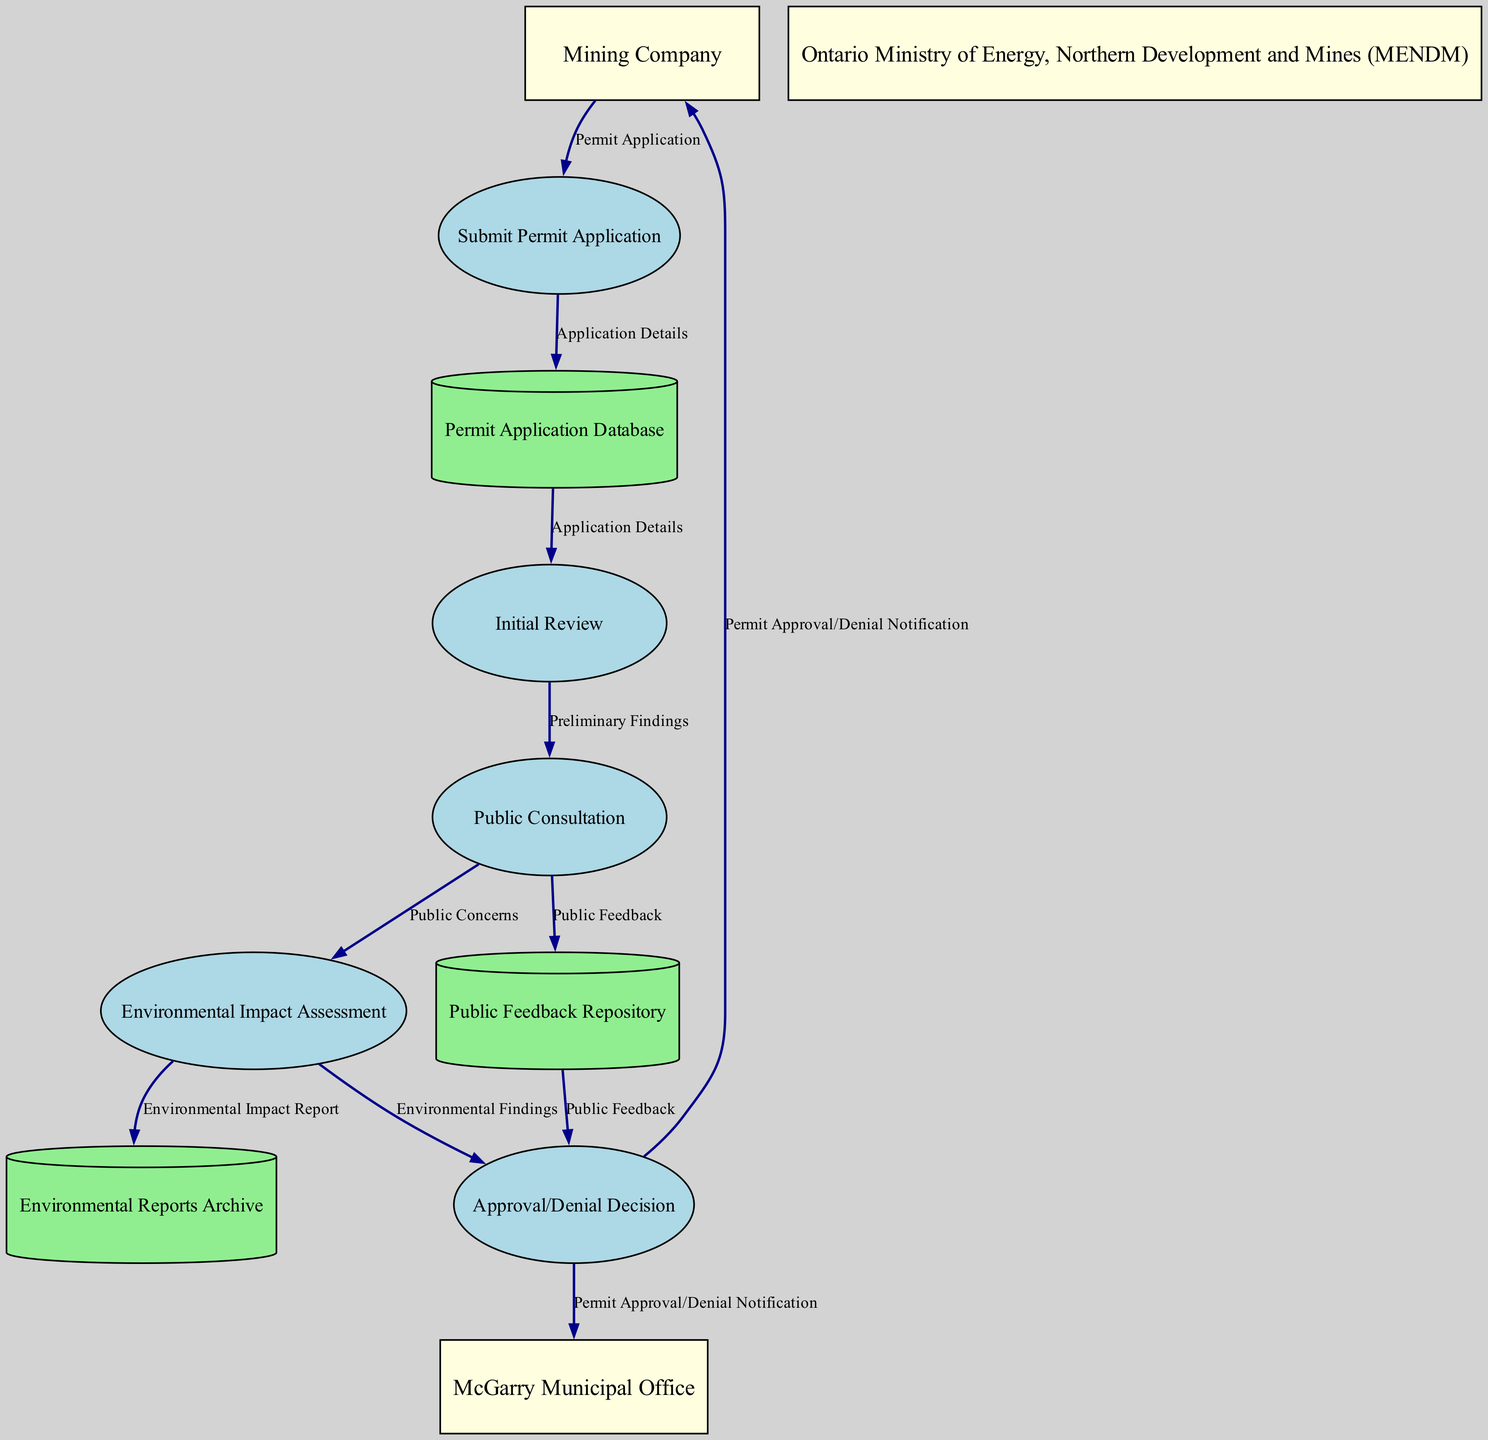What are the external entities in the diagram? The diagram lists three external entities: Mining Company, Ontario Ministry of Energy, Northern Development and Mines (MENDM), and McGarry Municipal Office. These entities are categorized separately as they interface with the mining permit application process.
Answer: Mining Company, Ontario Ministry of Energy, Northern Development and Mines (MENDM), McGarry Municipal Office How many processes are involved in the mining permit application workflow? There are five processes detailed in the diagram, namely: Submit Permit Application, Initial Review, Public Consultation, Environmental Impact Assessment, and Approval/Denial Decision. Counting each provides the total number of processes involved.
Answer: Five Which process immediately follows the Public Consultation process? After the Public Consultation process, the next step is the Environmental Impact Assessment. This can be verified by following the directional flow represented after Public Consultation in the data flow diagram.
Answer: Environmental Impact Assessment What data flow originates from the Mining Company? The flow titled Permit Application originates from the Mining Company, indicating that their action begins the process by creating a formal application submitted for further processing.
Answer: Permit Application Which two data stores receive outputs from the Environmental Impact Assessment? The Environmental Reports Archive and Approval/Denial Decision both receive outputs from the Environmental Impact Assessment. This can be understood by tracing the outcomes that lead from the assessment process to these two data stores.
Answer: Environmental Reports Archive, Approval/Denial Decision What triggers the Approval/Denial Decision process? The Approval/Denial Decision process is triggered by the Environmental Findings and the Public Feedback. This necessitates looking at the data flow connections directed into the Approval/Denial Decision to identify its inputs.
Answer: Environmental Findings, Public Feedback What does the McGarry Municipal Office receive from the Approval/Denial Decision? The McGarry Municipal Office receives a Permit Approval/Denial Notification from the Approval/Denial Decision, as indicated by the flow established between these two nodes.
Answer: Permit Approval/Denial Notification What is the purpose of the Public Feedback Repository? The Public Feedback Repository is used to store feedback collected from public consultations, playing a crucial role in keeping track of community input during the mining permit application process. This is determined from the flow from the Public Consultation process to this repository.
Answer: Store feedback collected from public consultations 